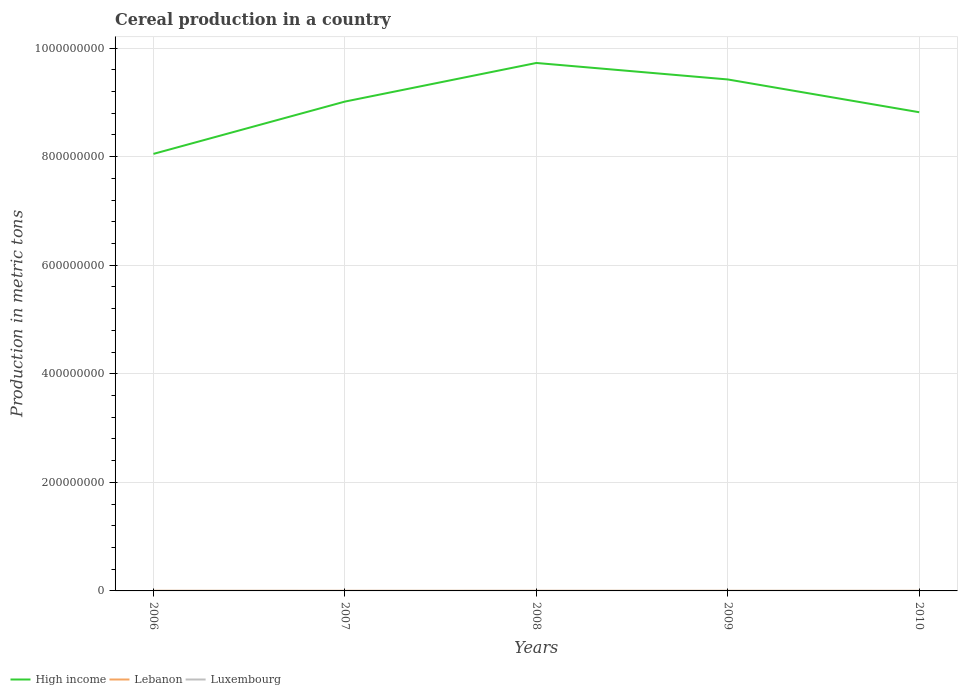Across all years, what is the maximum total cereal production in Luxembourg?
Offer a very short reply. 1.48e+05. In which year was the total cereal production in Lebanon maximum?
Your answer should be very brief. 2010. What is the total total cereal production in High income in the graph?
Give a very brief answer. -4.08e+07. What is the difference between the highest and the second highest total cereal production in Luxembourg?
Your response must be concise. 4.24e+04. What is the difference between the highest and the lowest total cereal production in Lebanon?
Offer a very short reply. 2. Is the total cereal production in High income strictly greater than the total cereal production in Luxembourg over the years?
Ensure brevity in your answer.  No. How many lines are there?
Your answer should be compact. 3. How many years are there in the graph?
Offer a terse response. 5. Does the graph contain grids?
Keep it short and to the point. Yes. Where does the legend appear in the graph?
Your answer should be very brief. Bottom left. How many legend labels are there?
Your answer should be very brief. 3. How are the legend labels stacked?
Provide a short and direct response. Horizontal. What is the title of the graph?
Ensure brevity in your answer.  Cereal production in a country. What is the label or title of the X-axis?
Make the answer very short. Years. What is the label or title of the Y-axis?
Offer a very short reply. Production in metric tons. What is the Production in metric tons of High income in 2006?
Give a very brief answer. 8.05e+08. What is the Production in metric tons of Lebanon in 2006?
Provide a short and direct response. 1.89e+05. What is the Production in metric tons in Luxembourg in 2006?
Offer a terse response. 1.61e+05. What is the Production in metric tons of High income in 2007?
Make the answer very short. 9.01e+08. What is the Production in metric tons in Lebanon in 2007?
Offer a very short reply. 1.53e+05. What is the Production in metric tons in Luxembourg in 2007?
Your answer should be compact. 1.48e+05. What is the Production in metric tons of High income in 2008?
Offer a very short reply. 9.73e+08. What is the Production in metric tons in Lebanon in 2008?
Ensure brevity in your answer.  1.77e+05. What is the Production in metric tons of Luxembourg in 2008?
Keep it short and to the point. 1.91e+05. What is the Production in metric tons of High income in 2009?
Offer a very short reply. 9.42e+08. What is the Production in metric tons in Lebanon in 2009?
Your answer should be compact. 1.47e+05. What is the Production in metric tons of Luxembourg in 2009?
Your response must be concise. 1.89e+05. What is the Production in metric tons in High income in 2010?
Provide a succinct answer. 8.82e+08. What is the Production in metric tons in Lebanon in 2010?
Keep it short and to the point. 1.12e+05. What is the Production in metric tons of Luxembourg in 2010?
Provide a short and direct response. 1.66e+05. Across all years, what is the maximum Production in metric tons in High income?
Offer a very short reply. 9.73e+08. Across all years, what is the maximum Production in metric tons of Lebanon?
Provide a succinct answer. 1.89e+05. Across all years, what is the maximum Production in metric tons of Luxembourg?
Your answer should be very brief. 1.91e+05. Across all years, what is the minimum Production in metric tons in High income?
Make the answer very short. 8.05e+08. Across all years, what is the minimum Production in metric tons of Lebanon?
Offer a terse response. 1.12e+05. Across all years, what is the minimum Production in metric tons of Luxembourg?
Provide a short and direct response. 1.48e+05. What is the total Production in metric tons in High income in the graph?
Your answer should be very brief. 4.50e+09. What is the total Production in metric tons in Lebanon in the graph?
Your response must be concise. 7.78e+05. What is the total Production in metric tons of Luxembourg in the graph?
Ensure brevity in your answer.  8.55e+05. What is the difference between the Production in metric tons in High income in 2006 and that in 2007?
Make the answer very short. -9.63e+07. What is the difference between the Production in metric tons in Lebanon in 2006 and that in 2007?
Keep it short and to the point. 3.60e+04. What is the difference between the Production in metric tons of Luxembourg in 2006 and that in 2007?
Provide a short and direct response. 1.31e+04. What is the difference between the Production in metric tons of High income in 2006 and that in 2008?
Your answer should be very brief. -1.67e+08. What is the difference between the Production in metric tons of Lebanon in 2006 and that in 2008?
Make the answer very short. 1.24e+04. What is the difference between the Production in metric tons in Luxembourg in 2006 and that in 2008?
Your answer should be compact. -2.93e+04. What is the difference between the Production in metric tons of High income in 2006 and that in 2009?
Provide a short and direct response. -1.37e+08. What is the difference between the Production in metric tons of Lebanon in 2006 and that in 2009?
Offer a terse response. 4.28e+04. What is the difference between the Production in metric tons of Luxembourg in 2006 and that in 2009?
Provide a short and direct response. -2.71e+04. What is the difference between the Production in metric tons of High income in 2006 and that in 2010?
Give a very brief answer. -7.67e+07. What is the difference between the Production in metric tons of Lebanon in 2006 and that in 2010?
Ensure brevity in your answer.  7.78e+04. What is the difference between the Production in metric tons of Luxembourg in 2006 and that in 2010?
Provide a succinct answer. -4723. What is the difference between the Production in metric tons of High income in 2007 and that in 2008?
Make the answer very short. -7.11e+07. What is the difference between the Production in metric tons in Lebanon in 2007 and that in 2008?
Your response must be concise. -2.36e+04. What is the difference between the Production in metric tons in Luxembourg in 2007 and that in 2008?
Offer a very short reply. -4.24e+04. What is the difference between the Production in metric tons of High income in 2007 and that in 2009?
Make the answer very short. -4.08e+07. What is the difference between the Production in metric tons of Lebanon in 2007 and that in 2009?
Keep it short and to the point. 6770. What is the difference between the Production in metric tons in Luxembourg in 2007 and that in 2009?
Keep it short and to the point. -4.02e+04. What is the difference between the Production in metric tons of High income in 2007 and that in 2010?
Your response must be concise. 1.96e+07. What is the difference between the Production in metric tons of Lebanon in 2007 and that in 2010?
Your answer should be compact. 4.18e+04. What is the difference between the Production in metric tons in Luxembourg in 2007 and that in 2010?
Your response must be concise. -1.78e+04. What is the difference between the Production in metric tons of High income in 2008 and that in 2009?
Offer a terse response. 3.04e+07. What is the difference between the Production in metric tons of Lebanon in 2008 and that in 2009?
Ensure brevity in your answer.  3.04e+04. What is the difference between the Production in metric tons in Luxembourg in 2008 and that in 2009?
Provide a short and direct response. 2160. What is the difference between the Production in metric tons of High income in 2008 and that in 2010?
Ensure brevity in your answer.  9.07e+07. What is the difference between the Production in metric tons of Lebanon in 2008 and that in 2010?
Your response must be concise. 6.54e+04. What is the difference between the Production in metric tons of Luxembourg in 2008 and that in 2010?
Ensure brevity in your answer.  2.45e+04. What is the difference between the Production in metric tons in High income in 2009 and that in 2010?
Offer a very short reply. 6.04e+07. What is the difference between the Production in metric tons of Lebanon in 2009 and that in 2010?
Keep it short and to the point. 3.50e+04. What is the difference between the Production in metric tons of Luxembourg in 2009 and that in 2010?
Provide a succinct answer. 2.24e+04. What is the difference between the Production in metric tons in High income in 2006 and the Production in metric tons in Lebanon in 2007?
Keep it short and to the point. 8.05e+08. What is the difference between the Production in metric tons in High income in 2006 and the Production in metric tons in Luxembourg in 2007?
Offer a very short reply. 8.05e+08. What is the difference between the Production in metric tons of Lebanon in 2006 and the Production in metric tons of Luxembourg in 2007?
Give a very brief answer. 4.10e+04. What is the difference between the Production in metric tons in High income in 2006 and the Production in metric tons in Lebanon in 2008?
Make the answer very short. 8.05e+08. What is the difference between the Production in metric tons in High income in 2006 and the Production in metric tons in Luxembourg in 2008?
Offer a terse response. 8.05e+08. What is the difference between the Production in metric tons in Lebanon in 2006 and the Production in metric tons in Luxembourg in 2008?
Ensure brevity in your answer.  -1322. What is the difference between the Production in metric tons in High income in 2006 and the Production in metric tons in Lebanon in 2009?
Your answer should be very brief. 8.05e+08. What is the difference between the Production in metric tons in High income in 2006 and the Production in metric tons in Luxembourg in 2009?
Give a very brief answer. 8.05e+08. What is the difference between the Production in metric tons of Lebanon in 2006 and the Production in metric tons of Luxembourg in 2009?
Keep it short and to the point. 838. What is the difference between the Production in metric tons in High income in 2006 and the Production in metric tons in Lebanon in 2010?
Offer a terse response. 8.05e+08. What is the difference between the Production in metric tons of High income in 2006 and the Production in metric tons of Luxembourg in 2010?
Offer a terse response. 8.05e+08. What is the difference between the Production in metric tons in Lebanon in 2006 and the Production in metric tons in Luxembourg in 2010?
Ensure brevity in your answer.  2.32e+04. What is the difference between the Production in metric tons of High income in 2007 and the Production in metric tons of Lebanon in 2008?
Your response must be concise. 9.01e+08. What is the difference between the Production in metric tons of High income in 2007 and the Production in metric tons of Luxembourg in 2008?
Your answer should be compact. 9.01e+08. What is the difference between the Production in metric tons in Lebanon in 2007 and the Production in metric tons in Luxembourg in 2008?
Offer a terse response. -3.74e+04. What is the difference between the Production in metric tons of High income in 2007 and the Production in metric tons of Lebanon in 2009?
Provide a short and direct response. 9.01e+08. What is the difference between the Production in metric tons in High income in 2007 and the Production in metric tons in Luxembourg in 2009?
Offer a terse response. 9.01e+08. What is the difference between the Production in metric tons of Lebanon in 2007 and the Production in metric tons of Luxembourg in 2009?
Provide a succinct answer. -3.52e+04. What is the difference between the Production in metric tons of High income in 2007 and the Production in metric tons of Lebanon in 2010?
Your answer should be compact. 9.01e+08. What is the difference between the Production in metric tons in High income in 2007 and the Production in metric tons in Luxembourg in 2010?
Make the answer very short. 9.01e+08. What is the difference between the Production in metric tons of Lebanon in 2007 and the Production in metric tons of Luxembourg in 2010?
Make the answer very short. -1.28e+04. What is the difference between the Production in metric tons in High income in 2008 and the Production in metric tons in Lebanon in 2009?
Offer a very short reply. 9.72e+08. What is the difference between the Production in metric tons of High income in 2008 and the Production in metric tons of Luxembourg in 2009?
Offer a very short reply. 9.72e+08. What is the difference between the Production in metric tons of Lebanon in 2008 and the Production in metric tons of Luxembourg in 2009?
Your response must be concise. -1.16e+04. What is the difference between the Production in metric tons in High income in 2008 and the Production in metric tons in Lebanon in 2010?
Offer a terse response. 9.72e+08. What is the difference between the Production in metric tons of High income in 2008 and the Production in metric tons of Luxembourg in 2010?
Your answer should be very brief. 9.72e+08. What is the difference between the Production in metric tons of Lebanon in 2008 and the Production in metric tons of Luxembourg in 2010?
Ensure brevity in your answer.  1.08e+04. What is the difference between the Production in metric tons of High income in 2009 and the Production in metric tons of Lebanon in 2010?
Provide a short and direct response. 9.42e+08. What is the difference between the Production in metric tons of High income in 2009 and the Production in metric tons of Luxembourg in 2010?
Ensure brevity in your answer.  9.42e+08. What is the difference between the Production in metric tons of Lebanon in 2009 and the Production in metric tons of Luxembourg in 2010?
Offer a terse response. -1.96e+04. What is the average Production in metric tons in High income per year?
Your answer should be very brief. 9.01e+08. What is the average Production in metric tons in Lebanon per year?
Your answer should be compact. 1.56e+05. What is the average Production in metric tons of Luxembourg per year?
Offer a terse response. 1.71e+05. In the year 2006, what is the difference between the Production in metric tons in High income and Production in metric tons in Lebanon?
Offer a terse response. 8.05e+08. In the year 2006, what is the difference between the Production in metric tons of High income and Production in metric tons of Luxembourg?
Make the answer very short. 8.05e+08. In the year 2006, what is the difference between the Production in metric tons in Lebanon and Production in metric tons in Luxembourg?
Make the answer very short. 2.79e+04. In the year 2007, what is the difference between the Production in metric tons of High income and Production in metric tons of Lebanon?
Your answer should be very brief. 9.01e+08. In the year 2007, what is the difference between the Production in metric tons of High income and Production in metric tons of Luxembourg?
Your answer should be compact. 9.01e+08. In the year 2007, what is the difference between the Production in metric tons of Lebanon and Production in metric tons of Luxembourg?
Ensure brevity in your answer.  5019. In the year 2008, what is the difference between the Production in metric tons in High income and Production in metric tons in Lebanon?
Keep it short and to the point. 9.72e+08. In the year 2008, what is the difference between the Production in metric tons of High income and Production in metric tons of Luxembourg?
Ensure brevity in your answer.  9.72e+08. In the year 2008, what is the difference between the Production in metric tons in Lebanon and Production in metric tons in Luxembourg?
Provide a succinct answer. -1.37e+04. In the year 2009, what is the difference between the Production in metric tons of High income and Production in metric tons of Lebanon?
Make the answer very short. 9.42e+08. In the year 2009, what is the difference between the Production in metric tons in High income and Production in metric tons in Luxembourg?
Provide a short and direct response. 9.42e+08. In the year 2009, what is the difference between the Production in metric tons in Lebanon and Production in metric tons in Luxembourg?
Give a very brief answer. -4.20e+04. In the year 2010, what is the difference between the Production in metric tons of High income and Production in metric tons of Lebanon?
Offer a very short reply. 8.82e+08. In the year 2010, what is the difference between the Production in metric tons in High income and Production in metric tons in Luxembourg?
Provide a short and direct response. 8.82e+08. In the year 2010, what is the difference between the Production in metric tons in Lebanon and Production in metric tons in Luxembourg?
Provide a short and direct response. -5.46e+04. What is the ratio of the Production in metric tons of High income in 2006 to that in 2007?
Your answer should be very brief. 0.89. What is the ratio of the Production in metric tons of Lebanon in 2006 to that in 2007?
Your answer should be compact. 1.23. What is the ratio of the Production in metric tons in Luxembourg in 2006 to that in 2007?
Provide a short and direct response. 1.09. What is the ratio of the Production in metric tons in High income in 2006 to that in 2008?
Make the answer very short. 0.83. What is the ratio of the Production in metric tons in Lebanon in 2006 to that in 2008?
Provide a short and direct response. 1.07. What is the ratio of the Production in metric tons of Luxembourg in 2006 to that in 2008?
Offer a very short reply. 0.85. What is the ratio of the Production in metric tons in High income in 2006 to that in 2009?
Make the answer very short. 0.85. What is the ratio of the Production in metric tons in Lebanon in 2006 to that in 2009?
Offer a terse response. 1.29. What is the ratio of the Production in metric tons in Luxembourg in 2006 to that in 2009?
Your answer should be very brief. 0.86. What is the ratio of the Production in metric tons in Lebanon in 2006 to that in 2010?
Keep it short and to the point. 1.7. What is the ratio of the Production in metric tons in Luxembourg in 2006 to that in 2010?
Provide a succinct answer. 0.97. What is the ratio of the Production in metric tons of High income in 2007 to that in 2008?
Give a very brief answer. 0.93. What is the ratio of the Production in metric tons of Lebanon in 2007 to that in 2008?
Provide a short and direct response. 0.87. What is the ratio of the Production in metric tons in Luxembourg in 2007 to that in 2008?
Provide a succinct answer. 0.78. What is the ratio of the Production in metric tons in High income in 2007 to that in 2009?
Provide a short and direct response. 0.96. What is the ratio of the Production in metric tons of Lebanon in 2007 to that in 2009?
Your answer should be compact. 1.05. What is the ratio of the Production in metric tons in Luxembourg in 2007 to that in 2009?
Give a very brief answer. 0.79. What is the ratio of the Production in metric tons of High income in 2007 to that in 2010?
Your answer should be compact. 1.02. What is the ratio of the Production in metric tons of Lebanon in 2007 to that in 2010?
Make the answer very short. 1.37. What is the ratio of the Production in metric tons in Luxembourg in 2007 to that in 2010?
Your answer should be compact. 0.89. What is the ratio of the Production in metric tons of High income in 2008 to that in 2009?
Offer a very short reply. 1.03. What is the ratio of the Production in metric tons of Lebanon in 2008 to that in 2009?
Offer a very short reply. 1.21. What is the ratio of the Production in metric tons in Luxembourg in 2008 to that in 2009?
Your answer should be very brief. 1.01. What is the ratio of the Production in metric tons in High income in 2008 to that in 2010?
Offer a very short reply. 1.1. What is the ratio of the Production in metric tons of Lebanon in 2008 to that in 2010?
Provide a succinct answer. 1.59. What is the ratio of the Production in metric tons in Luxembourg in 2008 to that in 2010?
Offer a terse response. 1.15. What is the ratio of the Production in metric tons of High income in 2009 to that in 2010?
Provide a succinct answer. 1.07. What is the ratio of the Production in metric tons in Lebanon in 2009 to that in 2010?
Ensure brevity in your answer.  1.31. What is the ratio of the Production in metric tons in Luxembourg in 2009 to that in 2010?
Ensure brevity in your answer.  1.13. What is the difference between the highest and the second highest Production in metric tons of High income?
Give a very brief answer. 3.04e+07. What is the difference between the highest and the second highest Production in metric tons in Lebanon?
Offer a very short reply. 1.24e+04. What is the difference between the highest and the second highest Production in metric tons of Luxembourg?
Your response must be concise. 2160. What is the difference between the highest and the lowest Production in metric tons in High income?
Make the answer very short. 1.67e+08. What is the difference between the highest and the lowest Production in metric tons in Lebanon?
Your answer should be very brief. 7.78e+04. What is the difference between the highest and the lowest Production in metric tons of Luxembourg?
Your response must be concise. 4.24e+04. 